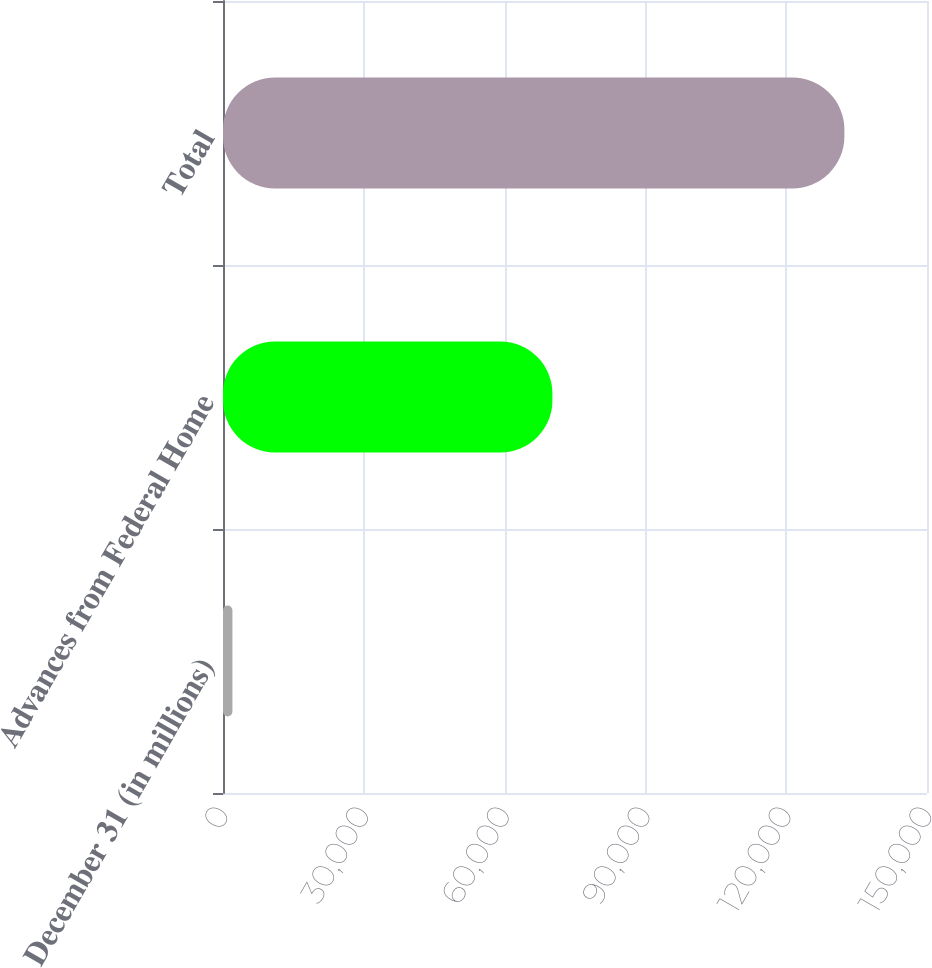Convert chart. <chart><loc_0><loc_0><loc_500><loc_500><bar_chart><fcel>December 31 (in millions)<fcel>Advances from Federal Home<fcel>Total<nl><fcel>2008<fcel>70187<fcel>132400<nl></chart> 